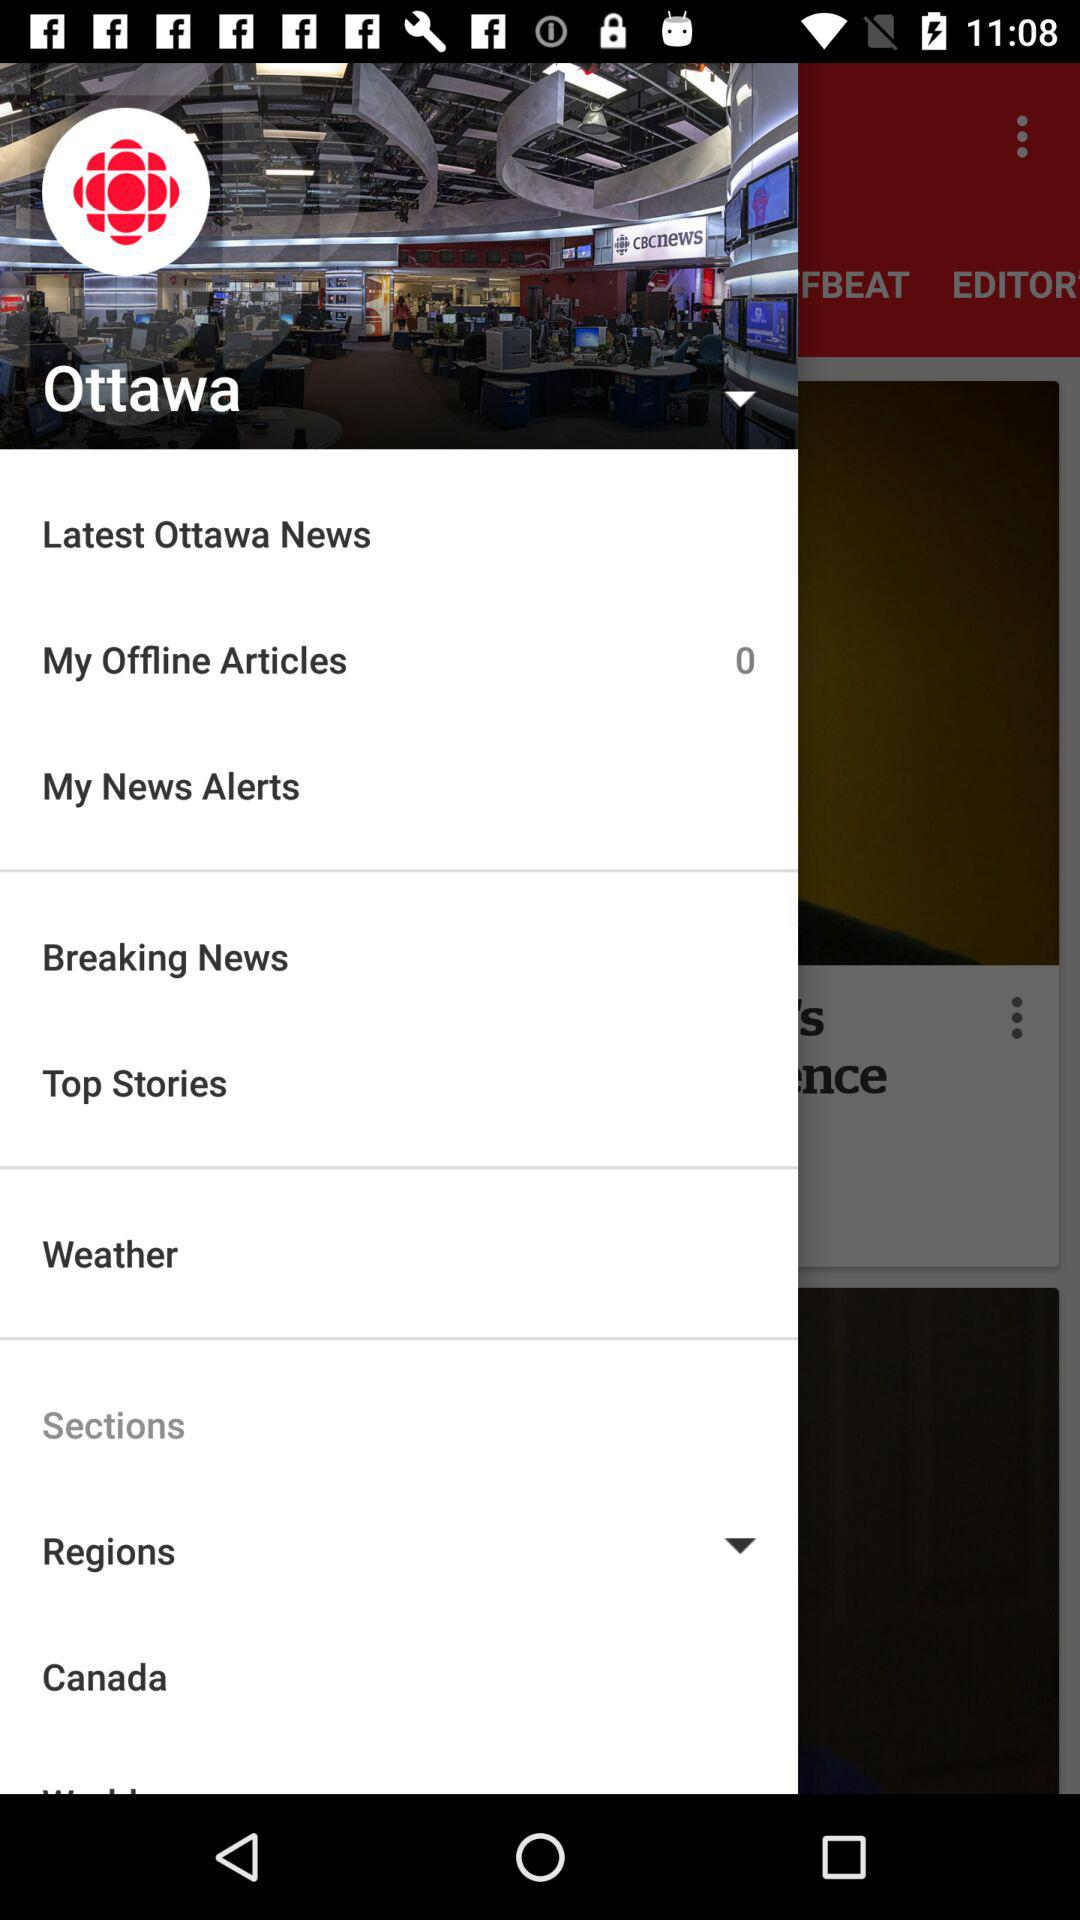How many offline articles are there? There are 0 offline articles. 